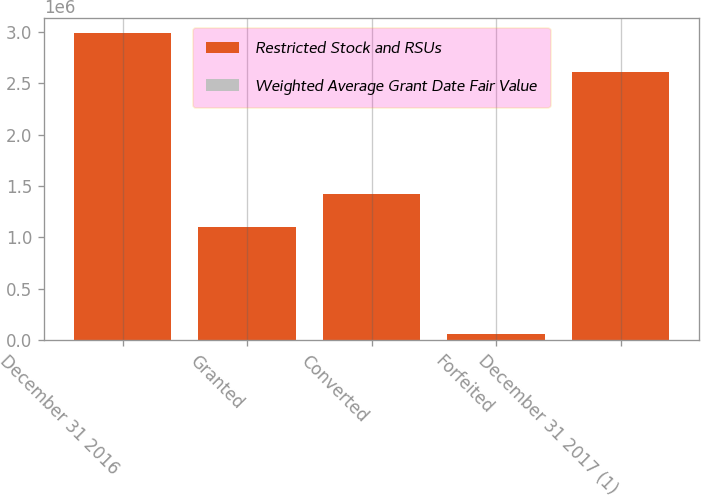Convert chart to OTSL. <chart><loc_0><loc_0><loc_500><loc_500><stacked_bar_chart><ecel><fcel>December 31 2016<fcel>Granted<fcel>Converted<fcel>Forfeited<fcel>December 31 2017 (1)<nl><fcel>Restricted Stock and RSUs<fcel>2.98759e+06<fcel>1.10421e+06<fcel>1.42465e+06<fcel>58481<fcel>2.60867e+06<nl><fcel>Weighted Average Grant Date Fair Value<fcel>318.04<fcel>381.62<fcel>321.12<fcel>339.17<fcel>342.79<nl></chart> 